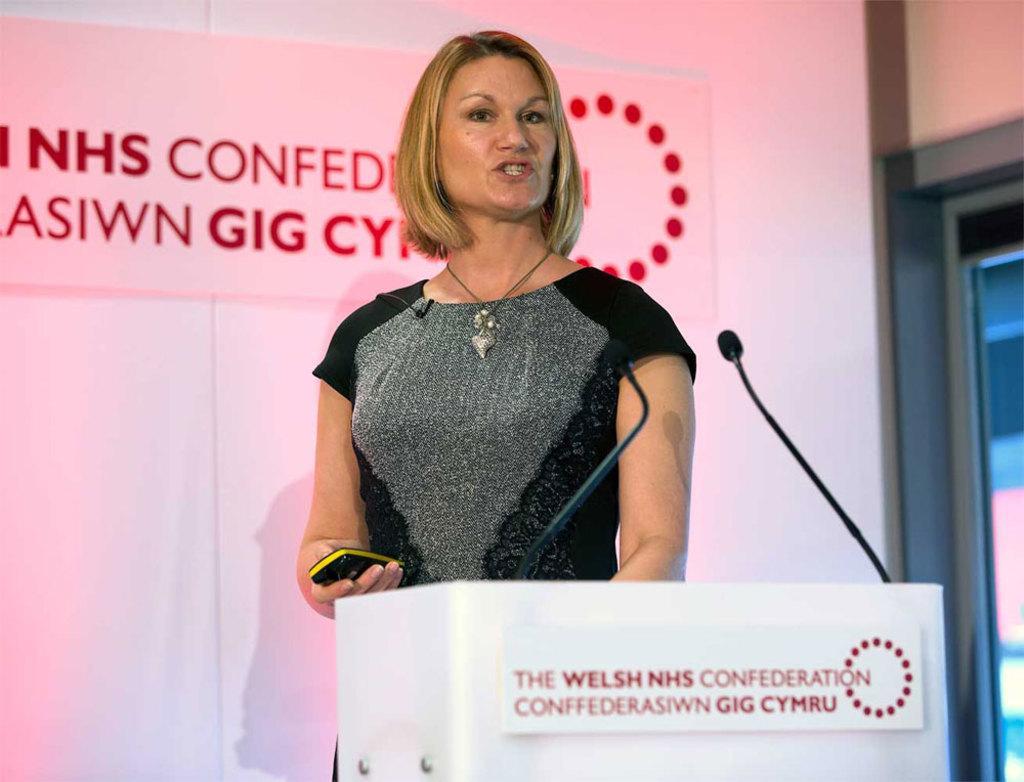Could you give a brief overview of what you see in this image? In the foreground of this picture, there is a woman standing near a podium holding a remote like structure in her hand. In front of her there are two mics. In the background, there is a screen, wall and a glass window. 